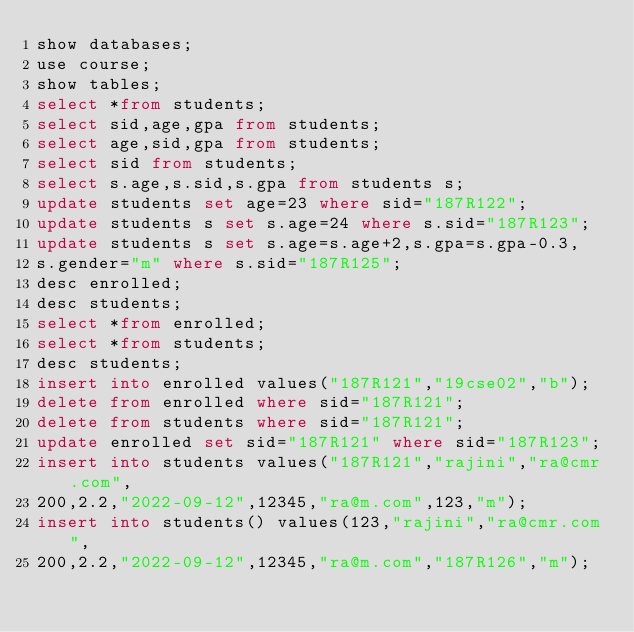Convert code to text. <code><loc_0><loc_0><loc_500><loc_500><_SQL_>show databases;
use course;
show tables;
select *from students;
select sid,age,gpa from students;
select age,sid,gpa from students;
select sid from students;
select s.age,s.sid,s.gpa from students s;
update students set age=23 where sid="187R122";
update students s set s.age=24 where s.sid="187R123";
update students s set s.age=s.age+2,s.gpa=s.gpa-0.3,
s.gender="m" where s.sid="187R125";
desc enrolled;
desc students;
select *from enrolled;
select *from students;
desc students;
insert into enrolled values("187R121","19cse02","b");
delete from enrolled where sid="187R121";
delete from students where sid="187R121";
update enrolled set sid="187R121" where sid="187R123";
insert into students values("187R121","rajini","ra@cmr.com",
200,2.2,"2022-09-12",12345,"ra@m.com",123,"m");
insert into students() values(123,"rajini","ra@cmr.com",
200,2.2,"2022-09-12",12345,"ra@m.com","187R126","m");</code> 